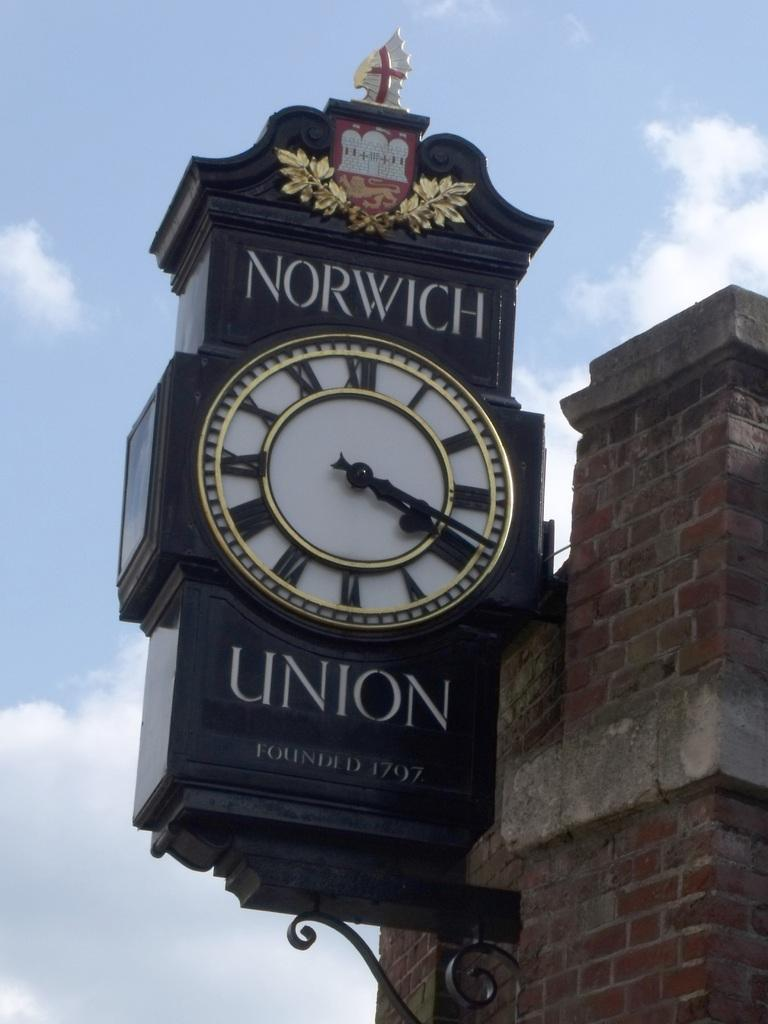<image>
Render a clear and concise summary of the photo. Norwich roman numeral union clock that was founded in 1797 